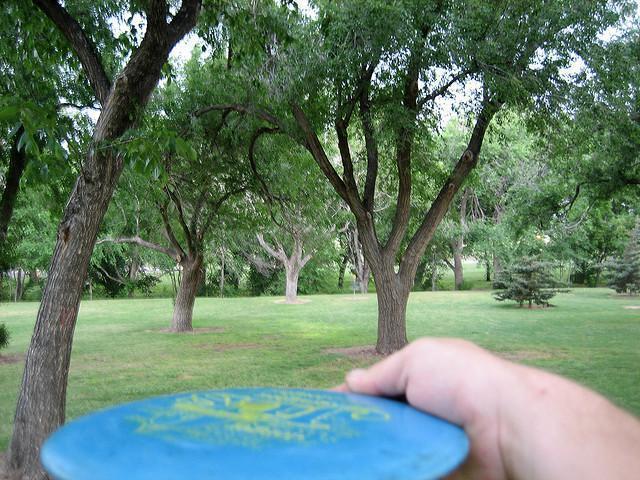How many cars are to the right?
Give a very brief answer. 0. 